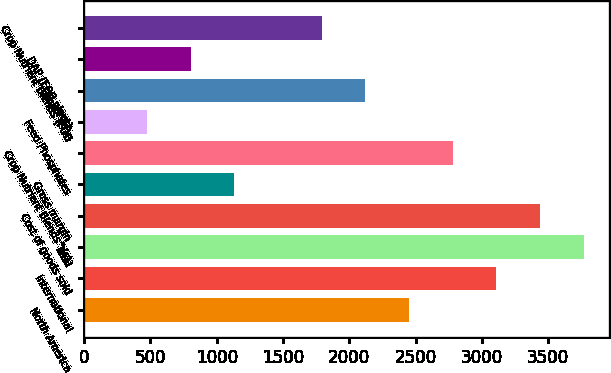Convert chart. <chart><loc_0><loc_0><loc_500><loc_500><bar_chart><fcel>North America<fcel>International<fcel>Total<fcel>Cost of goods sold<fcel>Gross margin<fcel>Crop Nutrient Blends^(c)<fcel>Feed Phosphates<fcel>Other^(d)<fcel>DAP (FOB plant)<fcel>Crop Nutrient Blends (FOB<nl><fcel>2450.24<fcel>3108.88<fcel>3767.52<fcel>3438.2<fcel>1132.96<fcel>2779.56<fcel>474.32<fcel>2120.92<fcel>803.64<fcel>1791.6<nl></chart> 